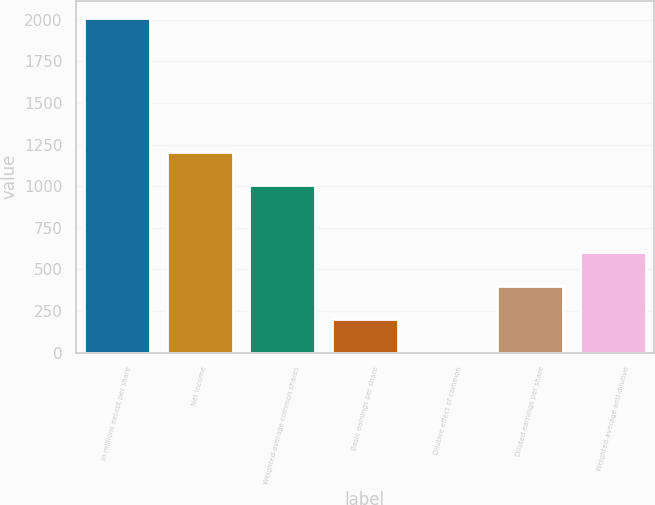Convert chart. <chart><loc_0><loc_0><loc_500><loc_500><bar_chart><fcel>In millions except per share<fcel>Net income<fcel>Weighted-average common shares<fcel>Basic earnings per share<fcel>Dilutive effect of common<fcel>Diluted earnings per share<fcel>Weighted-average anti-dilutive<nl><fcel>2012<fcel>1207.44<fcel>1006.3<fcel>201.74<fcel>0.6<fcel>402.88<fcel>604.02<nl></chart> 